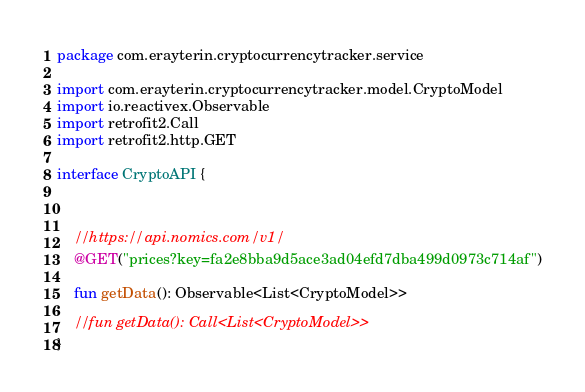<code> <loc_0><loc_0><loc_500><loc_500><_Kotlin_>package com.erayterin.cryptocurrencytracker.service

import com.erayterin.cryptocurrencytracker.model.CryptoModel
import io.reactivex.Observable
import retrofit2.Call
import retrofit2.http.GET

interface CryptoAPI {



    //https://api.nomics.com/v1/
    @GET("prices?key=fa2e8bba9d5ace3ad04efd7dba499d0973c714af")

    fun getData(): Observable<List<CryptoModel>>

    //fun getData(): Call<List<CryptoModel>>
}</code> 